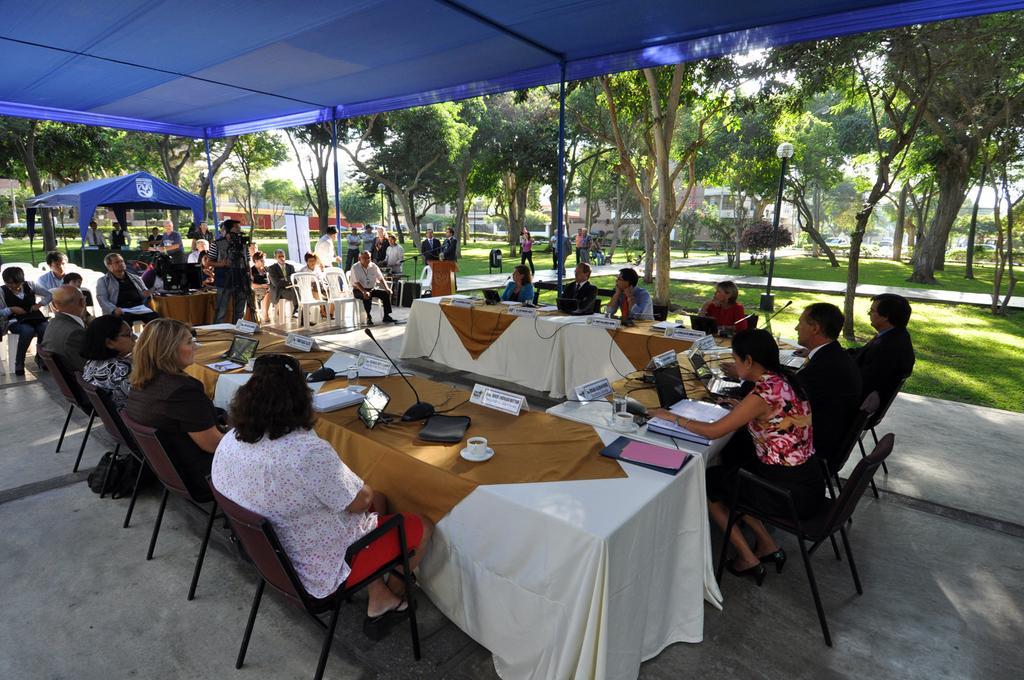How would you summarize this image in a sentence or two? This is a image inside of a tent and there are group of persons sitting on the chair and a camera man taking the picture of the persons and on the middle there is a another tent visible on the left corner and there are some trees visible on the left corner and on the right side there are some trees visible and there is a street light on the right corner. and on the middle there are some persons walking on the road and there is building visible on the right corner and center of the image there are tables kept and there are system kept on the table , coffee cup kept on the table. 